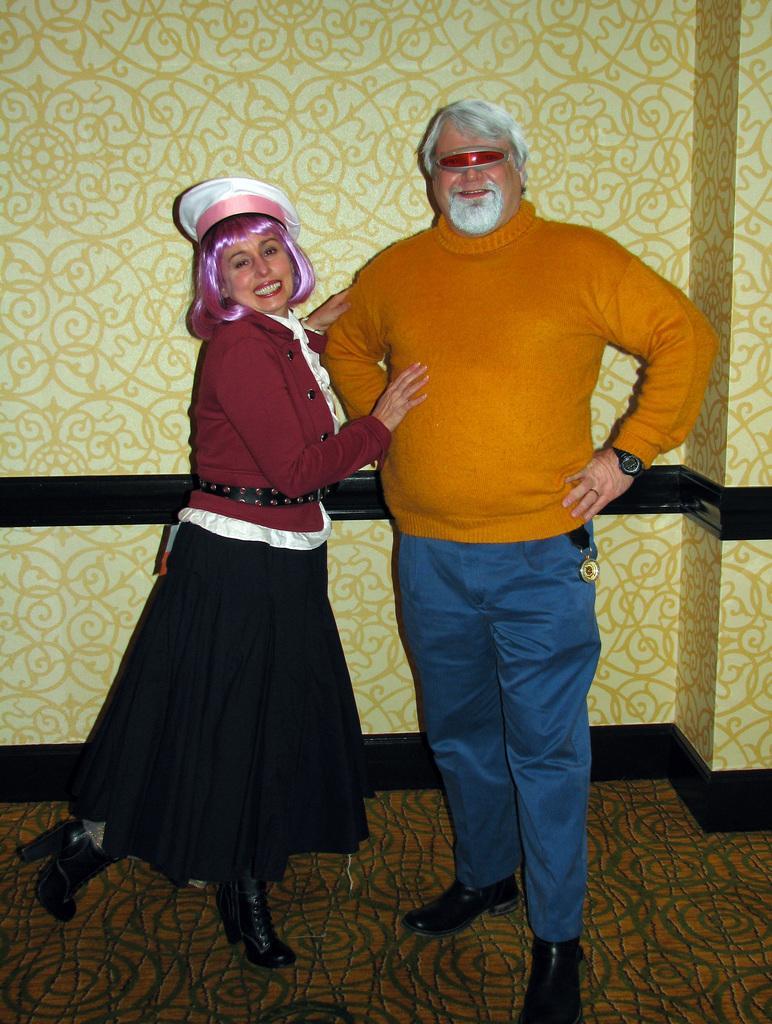Could you give a brief overview of what you see in this image? In this image there is a couple standing with a smile on their face is posing for the camera, behind them there is a wall. 